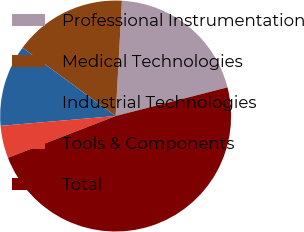Convert chart. <chart><loc_0><loc_0><loc_500><loc_500><pie_chart><fcel>Professional Instrumentation<fcel>Medical Technologies<fcel>Industrial Technologies<fcel>Tools & Components<fcel>Total<nl><fcel>20.14%<fcel>15.79%<fcel>11.43%<fcel>4.53%<fcel>48.1%<nl></chart> 